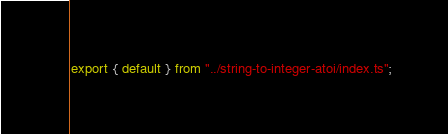<code> <loc_0><loc_0><loc_500><loc_500><_TypeScript_>export { default } from "../string-to-integer-atoi/index.ts";
</code> 